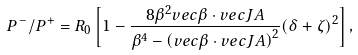<formula> <loc_0><loc_0><loc_500><loc_500>P ^ { - } / P ^ { + } = R _ { 0 } \left [ 1 - \frac { 8 \beta ^ { 2 } v e c { \beta } \cdot v e c { J } A } { \beta ^ { 4 } - \left ( v e c { \beta } \cdot v e c { J } A \right ) ^ { 2 } } ( \delta + \zeta ) ^ { 2 } \right ] ,</formula> 